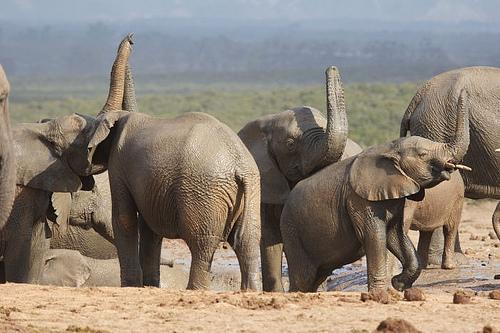How many elephants are there?
Give a very brief answer. 7. How many trunks are raised?
Give a very brief answer. 4. How many elephants are there?
Give a very brief answer. 7. 